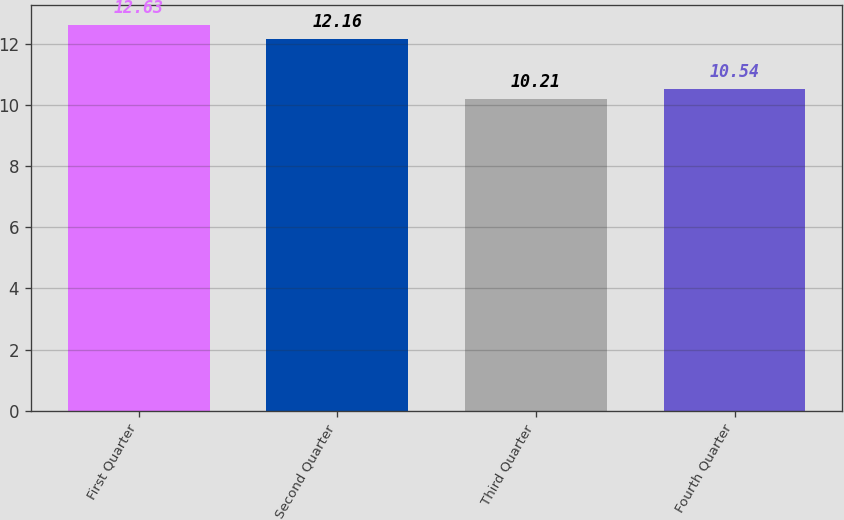Convert chart to OTSL. <chart><loc_0><loc_0><loc_500><loc_500><bar_chart><fcel>First Quarter<fcel>Second Quarter<fcel>Third Quarter<fcel>Fourth Quarter<nl><fcel>12.63<fcel>12.16<fcel>10.21<fcel>10.54<nl></chart> 